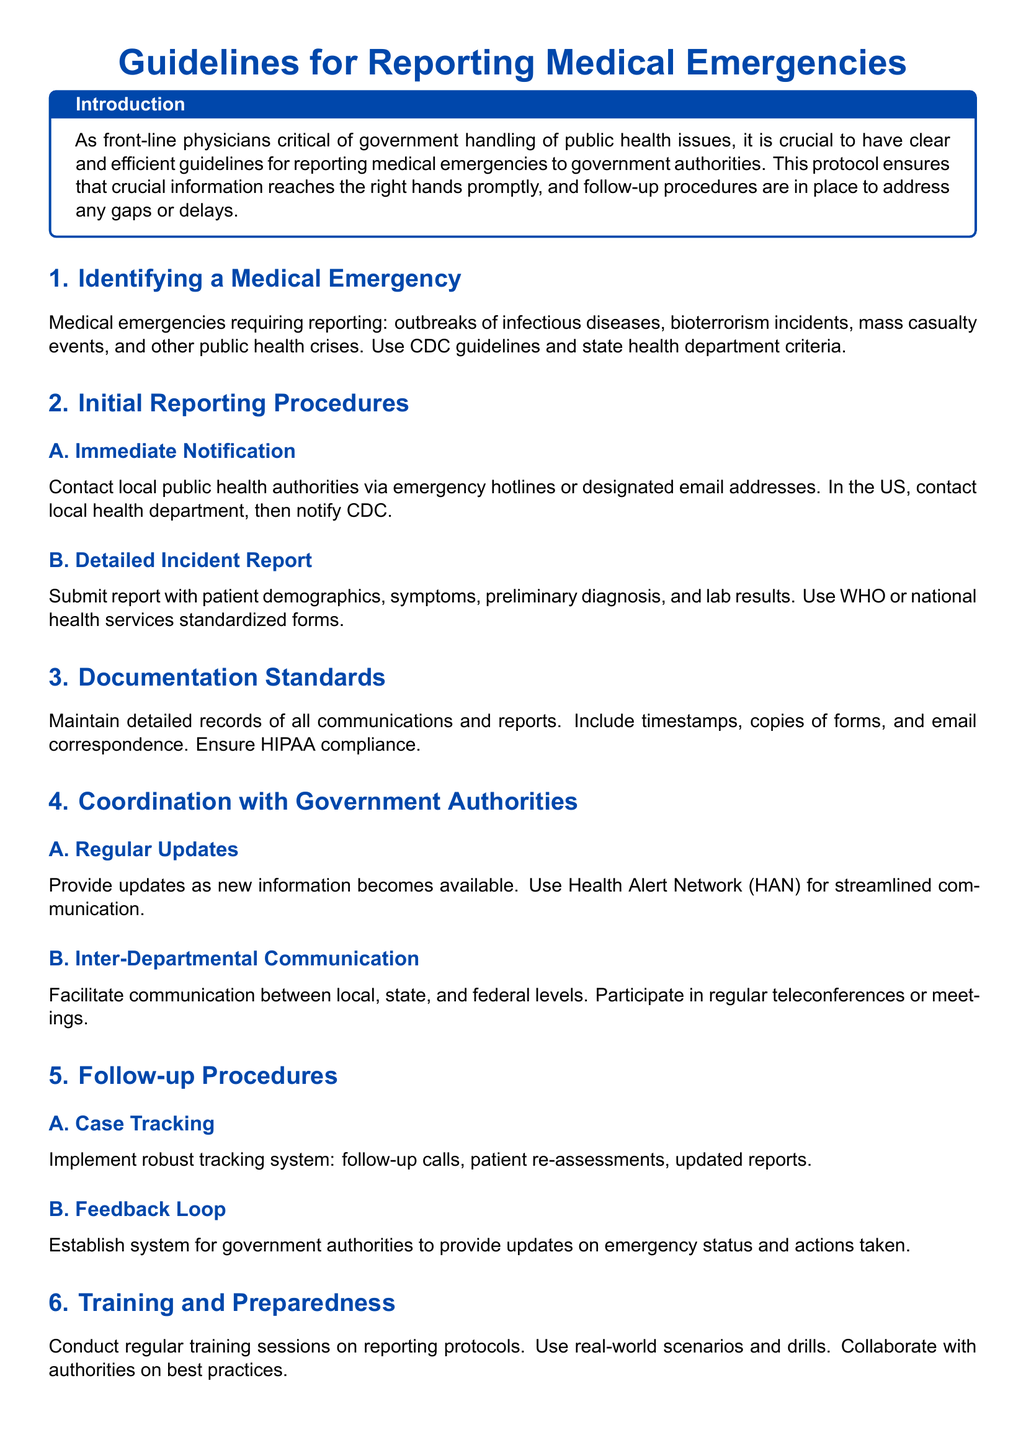What are the types of medical emergencies that require reporting? The document lists medical emergencies such as outbreaks of infectious diseases, bioterrorism incidents, mass casualty events, and other public health crises.
Answer: outbreaks of infectious diseases, bioterrorism incidents, mass casualty events, other public health crises What should be included in the detailed incident report? The report must include patient demographics, symptoms, preliminary diagnosis, and lab results according to the standards outlined in the document.
Answer: patient demographics, symptoms, preliminary diagnosis, lab results What is the purpose of the Health Alert Network (HAN)? The HAN is used for streamlined communication to provide regular updates during medical emergencies.
Answer: streamlined communication How often should training sessions on reporting protocols be conducted? Regular training sessions are recommended, which implies a consistent schedule for updates on reporting protocols.
Answer: regularly What type of system should be established for government feedback during emergencies? A feedback loop system should be established to keep communication open regarding emergency status and actions taken.
Answer: feedback loop What does the introduction emphasize regarding physician involvement? The introduction highlights the importance of having clear and efficient guidelines for reporting medical emergencies to government authorities.
Answer: clear and efficient guidelines What is required for maintaining documentation standards? The document states that all communications and reports must be maintained with detailed records and ensure HIPAA compliance.
Answer: detailed records, HIPAA compliance Which organization should be notified first in the US? The first notification should be made to the local health department according to the reporting procedures outlined.
Answer: local health department What is the significance of real-world scenarios in training? Real-world scenarios are used to prepare physicians effectively for handling reporting protocols during actual emergencies.
Answer: prepare effectively 